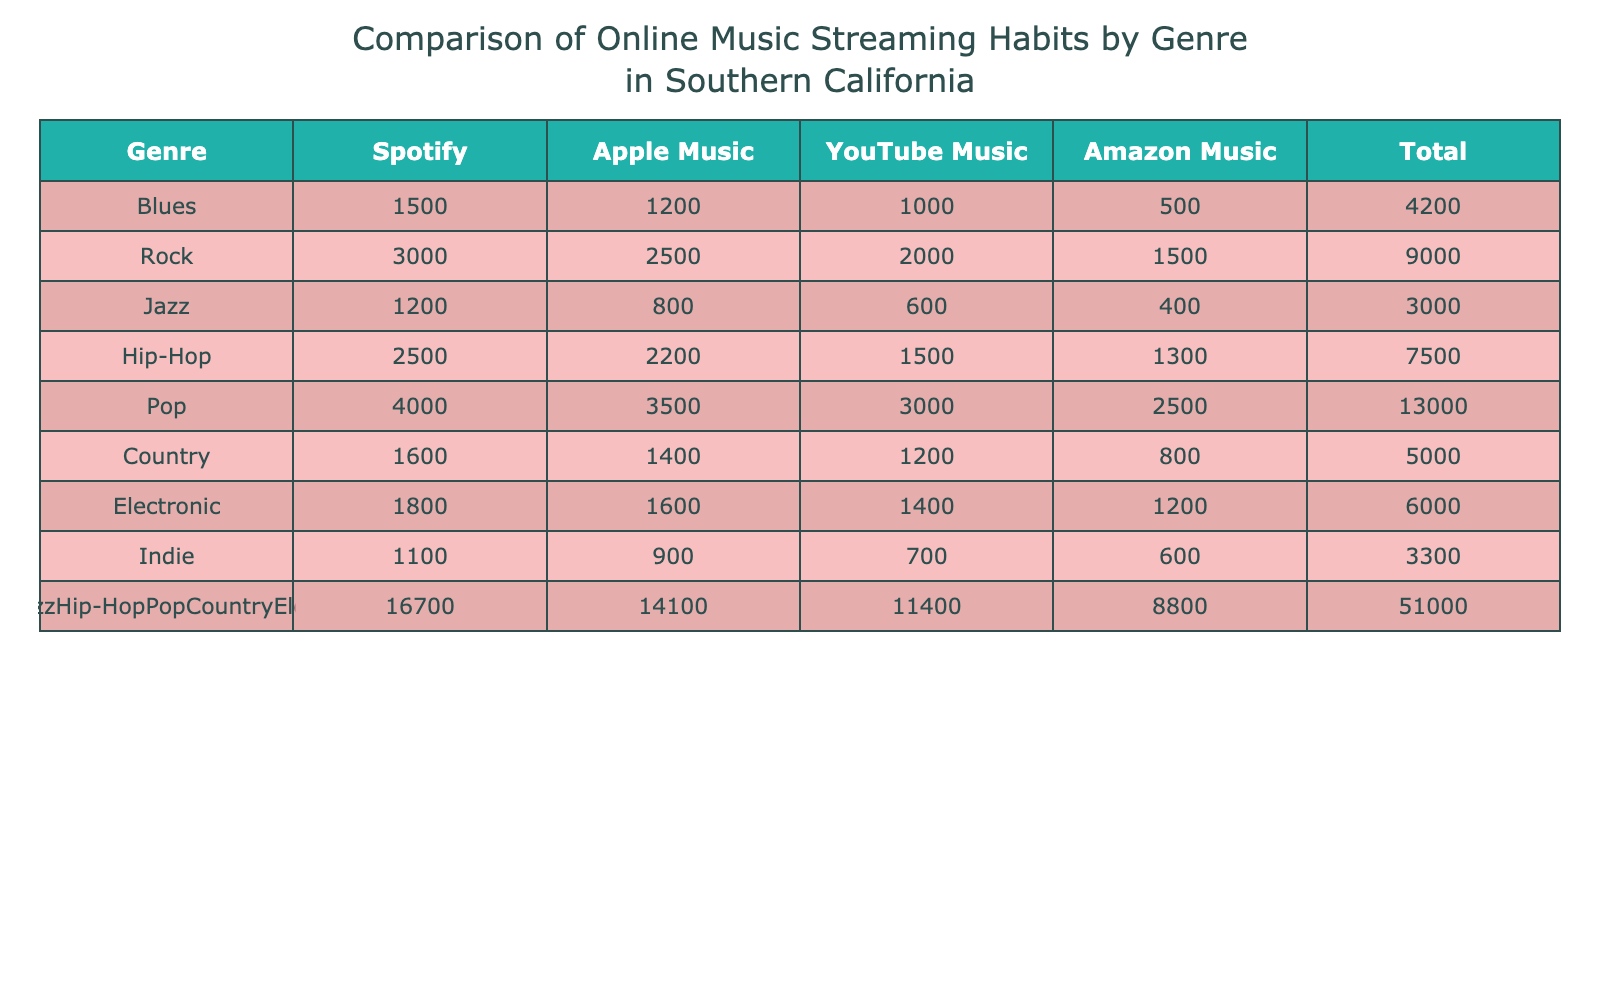What genre has the highest total streaming count? By looking at the total column in the table, we can see the numbers for each genre. The "Pop" genre has the highest total of 13,000 across all streaming platforms.
Answer: Pop How many more streams did "Rock" receive on Spotify compared to "Blues"? The number of streams for "Rock" on Spotify is 3,000 and for "Blues" is 1,500. Calculating the difference gives us 3,000 - 1,500 = 1,500.
Answer: 1500 Is the total streaming count for "Jazz" greater than that for "Country"? The total for "Jazz" is 3,000 and for "Country" it is 4,000. Since 3,000 is less than 4,000, the answer is no.
Answer: No What is the average number of streams across all genres on Apple Music? To find the average on Apple Music, we sum the streams (1,200 + 2,500 + 800 + 2,200 + 3,500 + 1,400 + 1,600 + 900) = 14,100, and then divide by the number of genres, which is 8. Thus, 14,100 / 8 = 1,762.5.
Answer: 1762.5 Which streaming service had the lowest number of streams for "Electronic"? The streaming counts for "Electronic" are 1,800 on Spotify, 1,600 on Apple Music, 1,400 on YouTube Music, and 1,200 on Amazon Music. Among these, Amazon Music has the lowest at 1,200.
Answer: Amazon Music What is the ratio of "Hip-Hop" streams on Spotify to "Indie" streams on YouTube Music? "Hip-Hop" has 2,500 streams on Spotify and "Indie" has 700 on YouTube Music. To find the ratio, we divide 2,500 by 700, giving us approximately 3.57.
Answer: 3.57 Does the total streaming count for "Blues" exceed the total for "Electronic"? The total for "Blues" is 4,200 and for "Electronic" it is 6,100. Since 4,200 is less than 6,100, the answer is no.
Answer: No What is the difference between the highest and lowest streaming counts for "Country" across all platforms? The highest streaming count for "Country" is 1,600 on Spotify and the lowest is 800 on Amazon Music. We calculate the difference: 1,600 - 800 = 800.
Answer: 800 